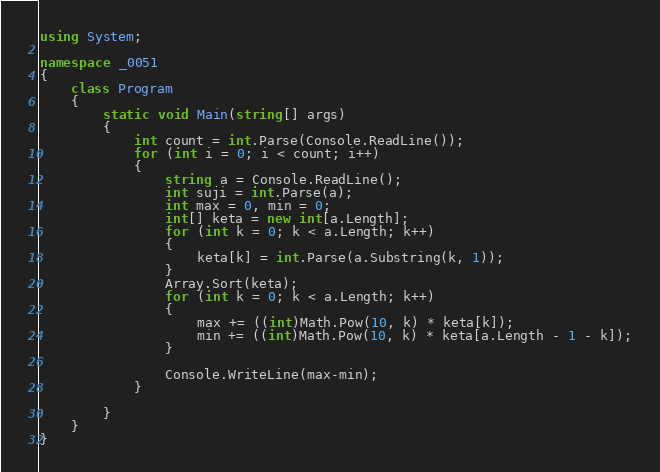<code> <loc_0><loc_0><loc_500><loc_500><_C#_>using System;

namespace _0051
{
    class Program
    {
        static void Main(string[] args)
        {
            int count = int.Parse(Console.ReadLine());
            for (int i = 0; i < count; i++)
            {
                string a = Console.ReadLine();
                int suji = int.Parse(a);
                int max = 0, min = 0;
                int[] keta = new int[a.Length];
                for (int k = 0; k < a.Length; k++)
                {
                    keta[k] = int.Parse(a.Substring(k, 1));
                }
                Array.Sort(keta);
                for (int k = 0; k < a.Length; k++)
                {
                    max += ((int)Math.Pow(10, k) * keta[k]);
                    min += ((int)Math.Pow(10, k) * keta[a.Length - 1 - k]);
                }

                Console.WriteLine(max-min);
            }

        }
    }
}</code> 